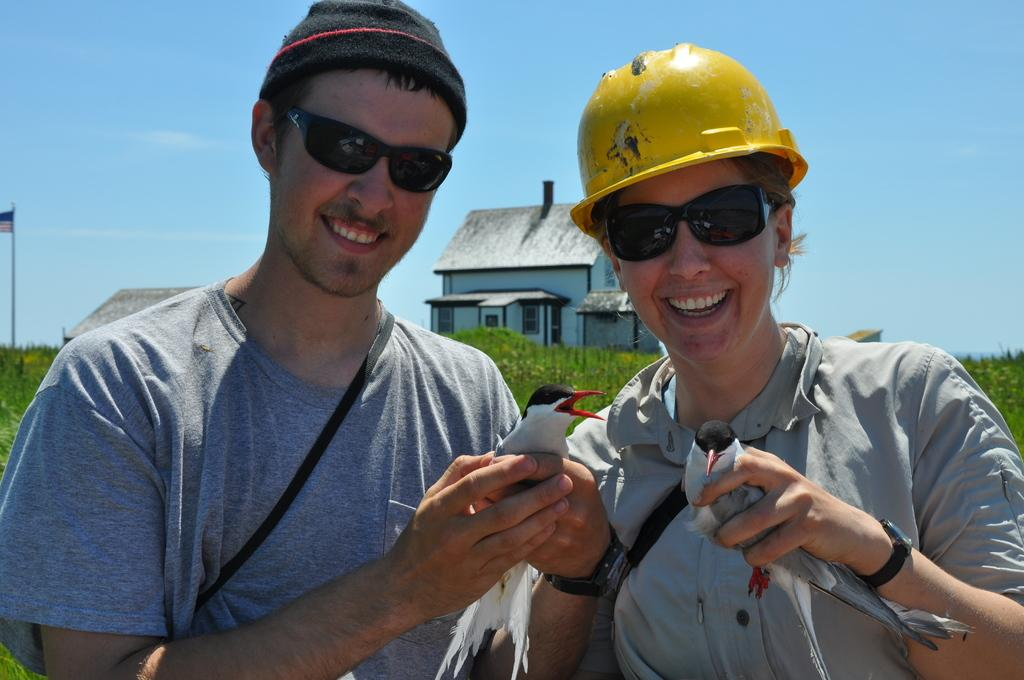Who is present in the image? There is a woman and a man in the image. What are the woman and man holding in the image? Both the woman and man are holding birds. What expressions do the woman and man have in the image? The woman and man are smiling. What can be seen in the background of the image? There are planets, houses, a pole with a flag, and the sky visible in the background of the image. What type of nut is being used to create the texture of the wax in the image? There is no nut or wax present in the image; it features a woman and a man holding birds, with a background that includes planets, houses, a pole with a flag, and the sky. 